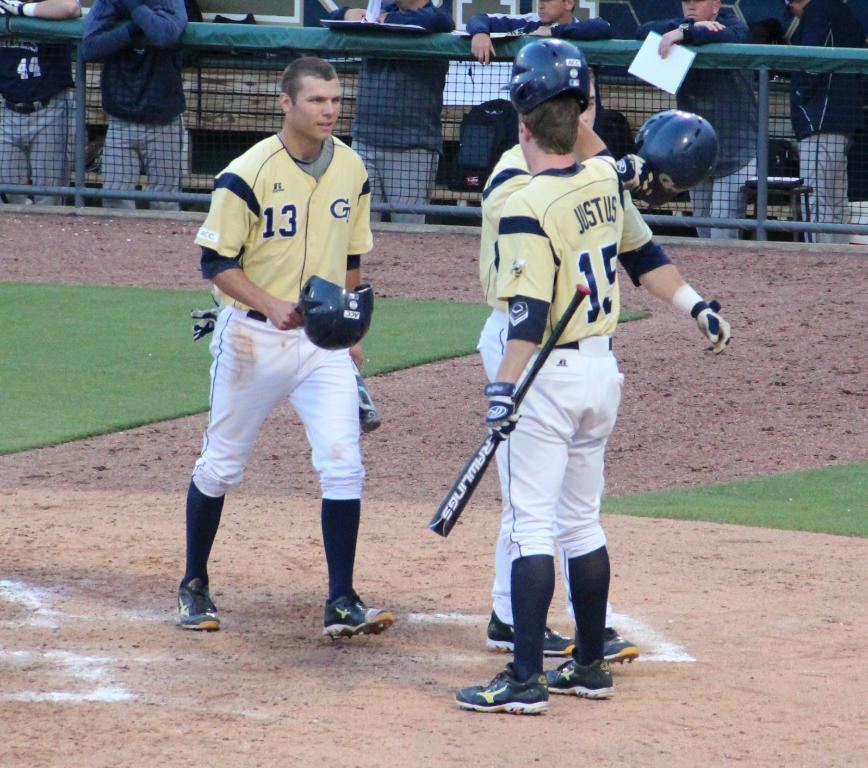Provide a one-sentence caption for the provided image. Player number 13 took their helmet off and is approaching player number 15. 